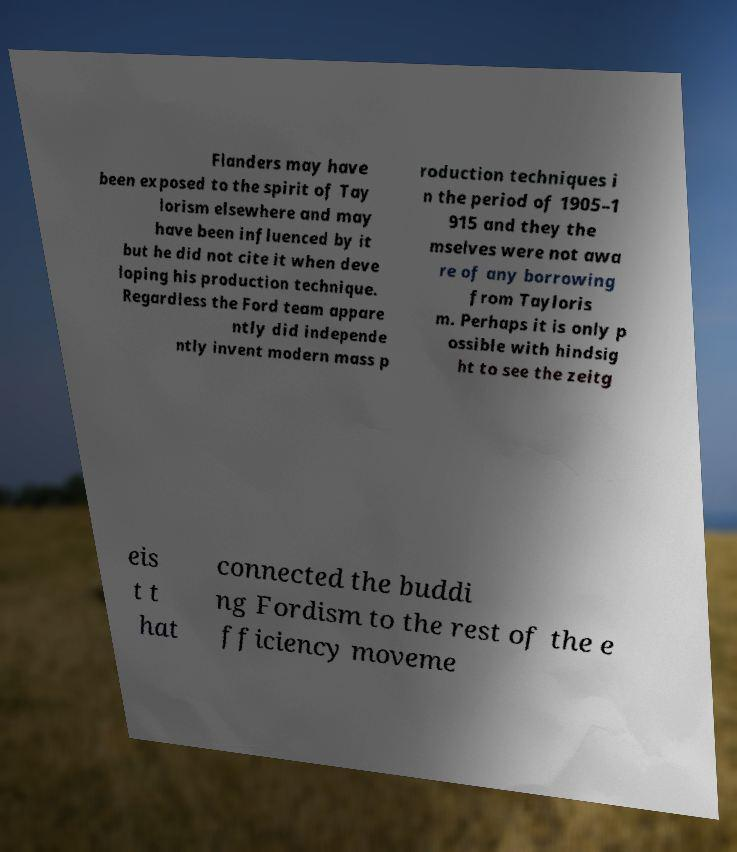Could you assist in decoding the text presented in this image and type it out clearly? Flanders may have been exposed to the spirit of Tay lorism elsewhere and may have been influenced by it but he did not cite it when deve loping his production technique. Regardless the Ford team appare ntly did independe ntly invent modern mass p roduction techniques i n the period of 1905–1 915 and they the mselves were not awa re of any borrowing from Tayloris m. Perhaps it is only p ossible with hindsig ht to see the zeitg eis t t hat connected the buddi ng Fordism to the rest of the e fficiency moveme 